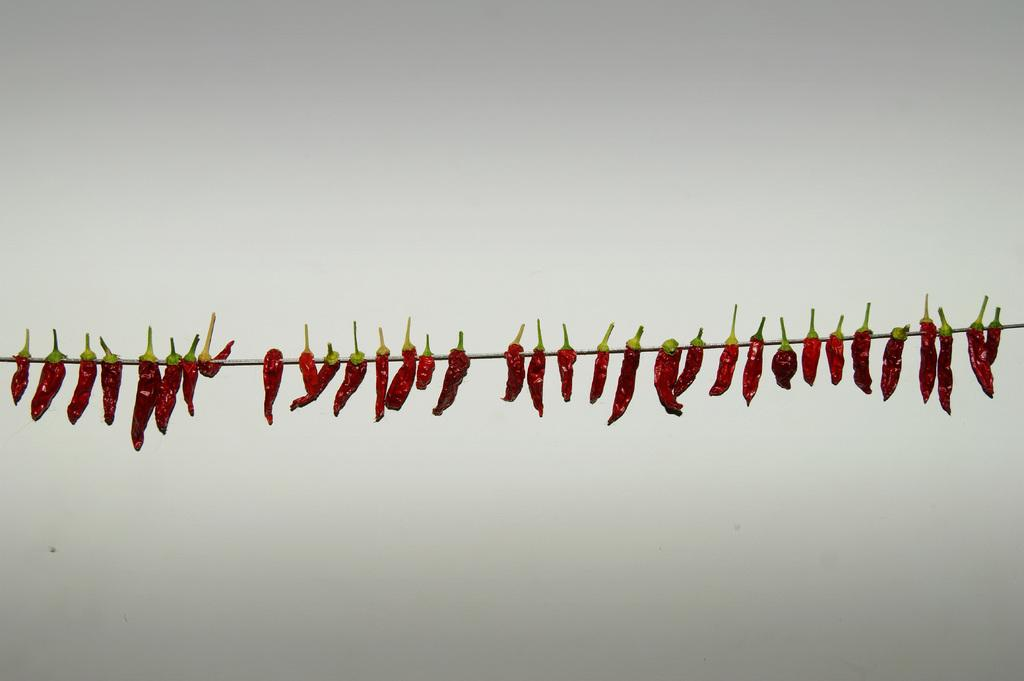What type of food is visible in the image? There are red chilies in the image. How are the red chilies arranged or connected? The red chilies are tied to a rope. What can be seen in the background of the image? There is a wall in the image. What type of box is being used to transport the red chilies in the image? There is no box or transportation depicted in the image; it only shows red chilies tied to a rope. Can you tell me where the locket is located in the image? There is no locket present in the image. 